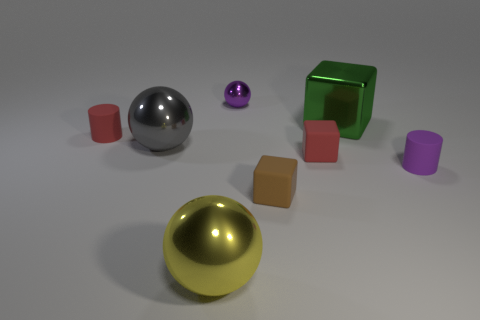There is a purple object to the left of the small cylinder on the right side of the red matte cylinder; are there any brown rubber objects left of it?
Provide a succinct answer. No. What material is the other yellow object that is the same shape as the tiny metal thing?
Ensure brevity in your answer.  Metal. Is there anything else that has the same material as the tiny brown object?
Give a very brief answer. Yes. How many blocks are tiny brown things or tiny red matte objects?
Ensure brevity in your answer.  2. There is a matte cube that is behind the purple rubber object; is it the same size as the cylinder on the right side of the gray metallic ball?
Ensure brevity in your answer.  Yes. The tiny purple thing in front of the tiny red object that is to the left of the brown thing is made of what material?
Provide a short and direct response. Rubber. Are there fewer small metal things that are on the right side of the large cube than brown metallic spheres?
Provide a short and direct response. No. What shape is the large gray thing that is the same material as the yellow object?
Your answer should be very brief. Sphere. What number of other objects are there of the same shape as the large gray metal thing?
Keep it short and to the point. 2. What number of gray objects are either matte blocks or large objects?
Your response must be concise. 1. 